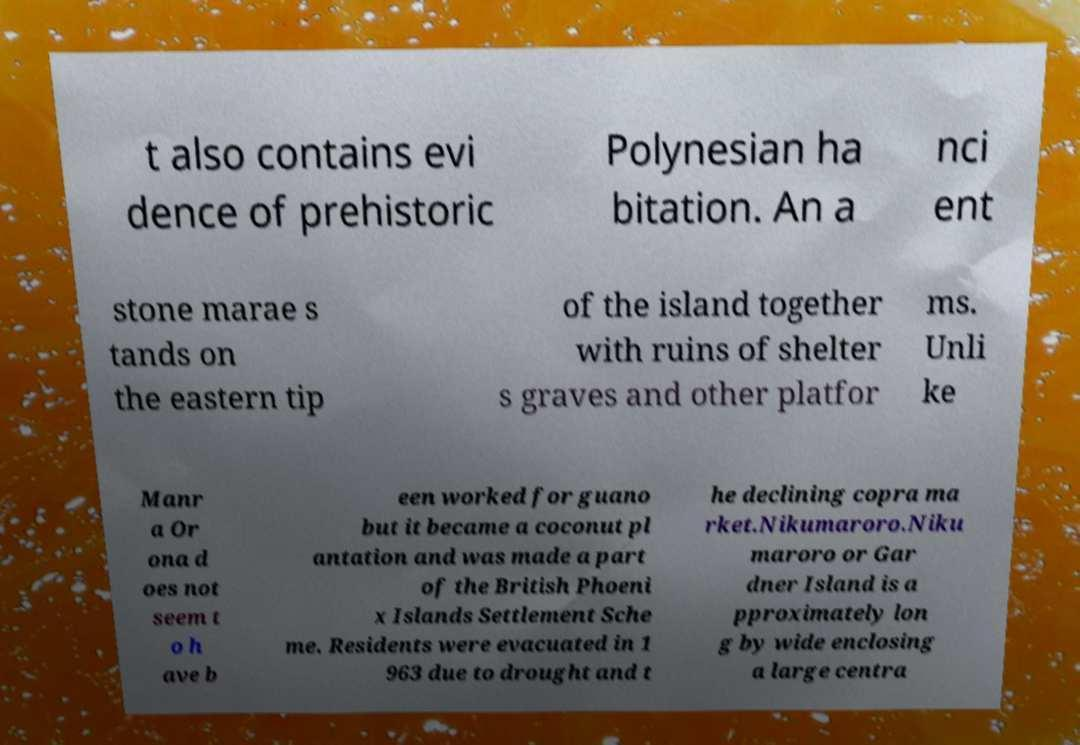I need the written content from this picture converted into text. Can you do that? t also contains evi dence of prehistoric Polynesian ha bitation. An a nci ent stone marae s tands on the eastern tip of the island together with ruins of shelter s graves and other platfor ms. Unli ke Manr a Or ona d oes not seem t o h ave b een worked for guano but it became a coconut pl antation and was made a part of the British Phoeni x Islands Settlement Sche me. Residents were evacuated in 1 963 due to drought and t he declining copra ma rket.Nikumaroro.Niku maroro or Gar dner Island is a pproximately lon g by wide enclosing a large centra 